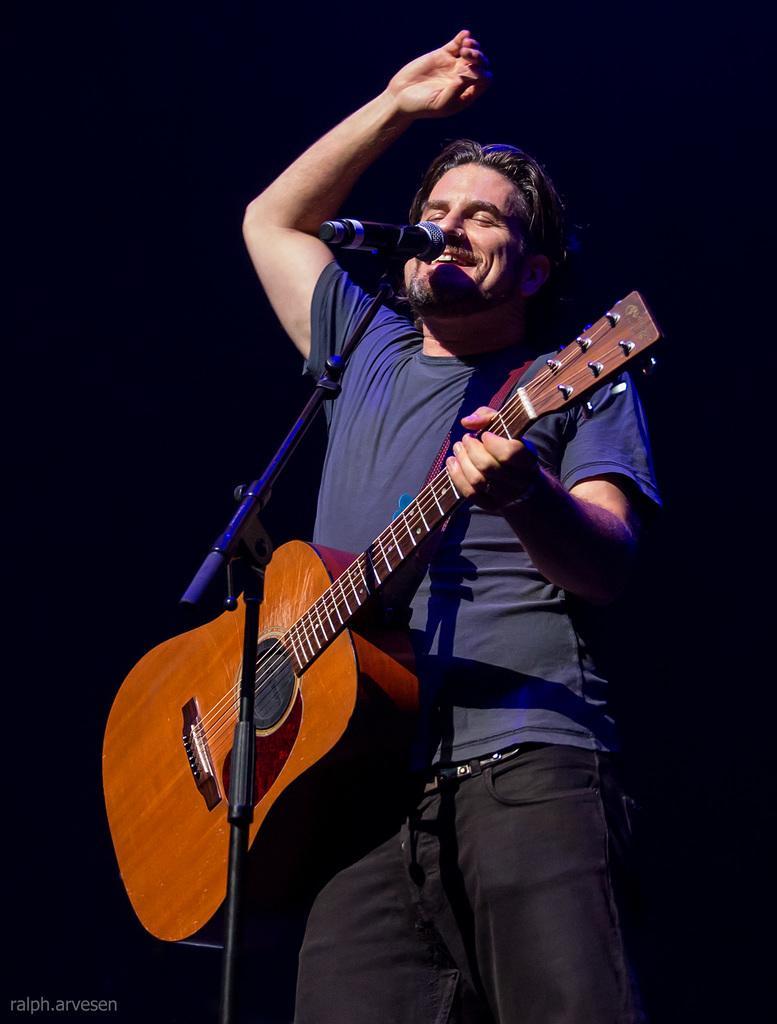Could you give a brief overview of what you see in this image? In this picture a guy who is wearing a blue shirt is playing a guitar and singing through a mic placed in front of him. The background is black in color. 